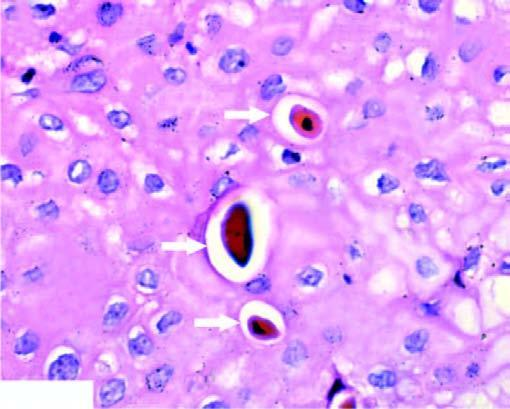what has clumped chromatin?
Answer the question using a single word or phrase. The nucleus 